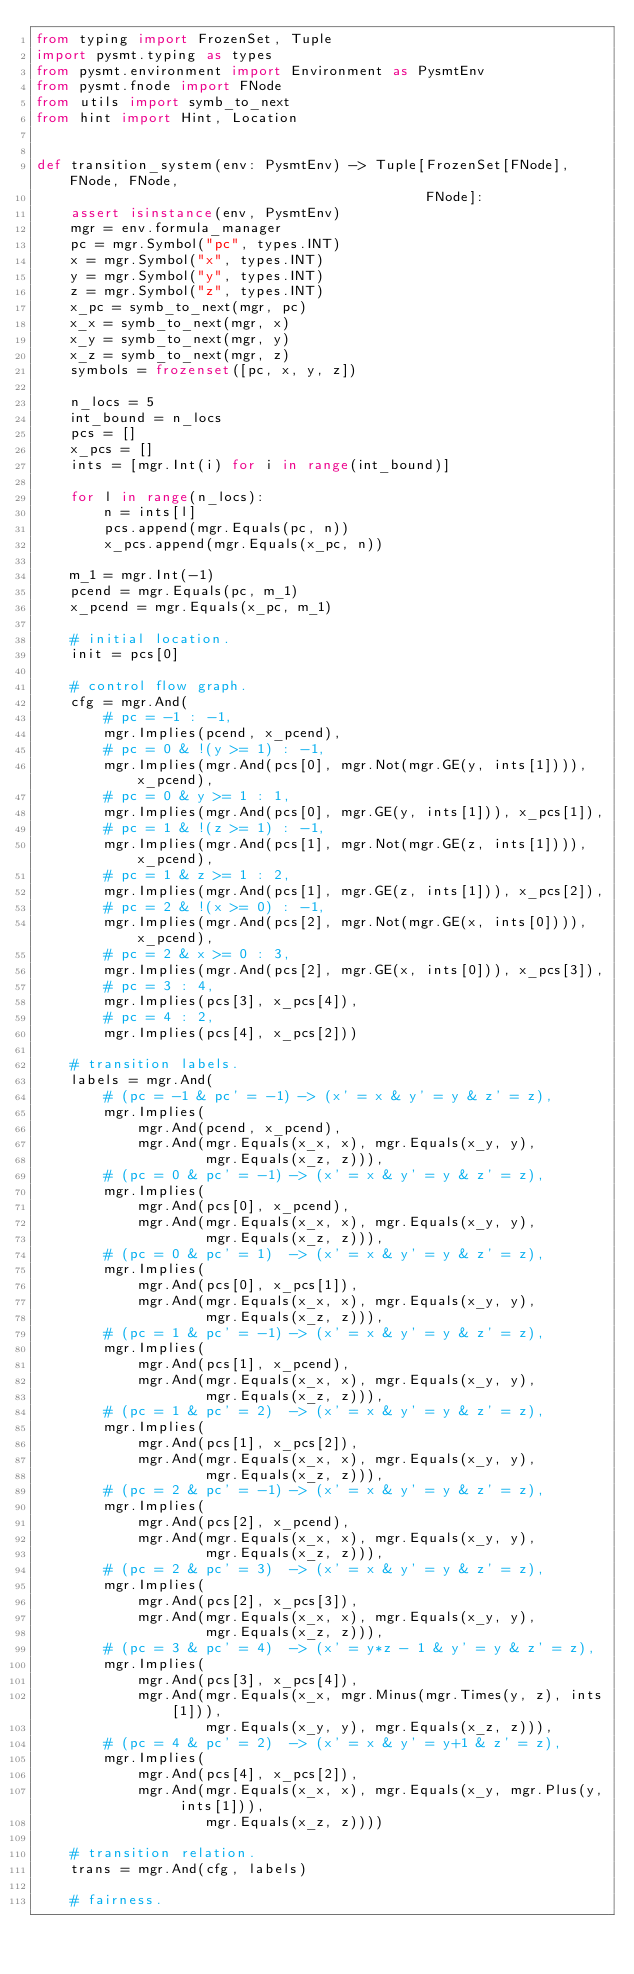Convert code to text. <code><loc_0><loc_0><loc_500><loc_500><_Python_>from typing import FrozenSet, Tuple
import pysmt.typing as types
from pysmt.environment import Environment as PysmtEnv
from pysmt.fnode import FNode
from utils import symb_to_next
from hint import Hint, Location


def transition_system(env: PysmtEnv) -> Tuple[FrozenSet[FNode], FNode, FNode,
                                              FNode]:
    assert isinstance(env, PysmtEnv)
    mgr = env.formula_manager
    pc = mgr.Symbol("pc", types.INT)
    x = mgr.Symbol("x", types.INT)
    y = mgr.Symbol("y", types.INT)
    z = mgr.Symbol("z", types.INT)
    x_pc = symb_to_next(mgr, pc)
    x_x = symb_to_next(mgr, x)
    x_y = symb_to_next(mgr, y)
    x_z = symb_to_next(mgr, z)
    symbols = frozenset([pc, x, y, z])

    n_locs = 5
    int_bound = n_locs
    pcs = []
    x_pcs = []
    ints = [mgr.Int(i) for i in range(int_bound)]

    for l in range(n_locs):
        n = ints[l]
        pcs.append(mgr.Equals(pc, n))
        x_pcs.append(mgr.Equals(x_pc, n))

    m_1 = mgr.Int(-1)
    pcend = mgr.Equals(pc, m_1)
    x_pcend = mgr.Equals(x_pc, m_1)

    # initial location.
    init = pcs[0]

    # control flow graph.
    cfg = mgr.And(
        # pc = -1 : -1,
        mgr.Implies(pcend, x_pcend),
        # pc = 0 & !(y >= 1) : -1,
        mgr.Implies(mgr.And(pcs[0], mgr.Not(mgr.GE(y, ints[1]))), x_pcend),
        # pc = 0 & y >= 1 : 1,
        mgr.Implies(mgr.And(pcs[0], mgr.GE(y, ints[1])), x_pcs[1]),
        # pc = 1 & !(z >= 1) : -1,
        mgr.Implies(mgr.And(pcs[1], mgr.Not(mgr.GE(z, ints[1]))), x_pcend),
        # pc = 1 & z >= 1 : 2,
        mgr.Implies(mgr.And(pcs[1], mgr.GE(z, ints[1])), x_pcs[2]),
        # pc = 2 & !(x >= 0) : -1,
        mgr.Implies(mgr.And(pcs[2], mgr.Not(mgr.GE(x, ints[0]))), x_pcend),
        # pc = 2 & x >= 0 : 3,
        mgr.Implies(mgr.And(pcs[2], mgr.GE(x, ints[0])), x_pcs[3]),
        # pc = 3 : 4,
        mgr.Implies(pcs[3], x_pcs[4]),
        # pc = 4 : 2,
        mgr.Implies(pcs[4], x_pcs[2]))

    # transition labels.
    labels = mgr.And(
        # (pc = -1 & pc' = -1) -> (x' = x & y' = y & z' = z),
        mgr.Implies(
            mgr.And(pcend, x_pcend),
            mgr.And(mgr.Equals(x_x, x), mgr.Equals(x_y, y),
                    mgr.Equals(x_z, z))),
        # (pc = 0 & pc' = -1) -> (x' = x & y' = y & z' = z),
        mgr.Implies(
            mgr.And(pcs[0], x_pcend),
            mgr.And(mgr.Equals(x_x, x), mgr.Equals(x_y, y),
                    mgr.Equals(x_z, z))),
        # (pc = 0 & pc' = 1)  -> (x' = x & y' = y & z' = z),
        mgr.Implies(
            mgr.And(pcs[0], x_pcs[1]),
            mgr.And(mgr.Equals(x_x, x), mgr.Equals(x_y, y),
                    mgr.Equals(x_z, z))),
        # (pc = 1 & pc' = -1) -> (x' = x & y' = y & z' = z),
        mgr.Implies(
            mgr.And(pcs[1], x_pcend),
            mgr.And(mgr.Equals(x_x, x), mgr.Equals(x_y, y),
                    mgr.Equals(x_z, z))),
        # (pc = 1 & pc' = 2)  -> (x' = x & y' = y & z' = z),
        mgr.Implies(
            mgr.And(pcs[1], x_pcs[2]),
            mgr.And(mgr.Equals(x_x, x), mgr.Equals(x_y, y),
                    mgr.Equals(x_z, z))),
        # (pc = 2 & pc' = -1) -> (x' = x & y' = y & z' = z),
        mgr.Implies(
            mgr.And(pcs[2], x_pcend),
            mgr.And(mgr.Equals(x_x, x), mgr.Equals(x_y, y),
                    mgr.Equals(x_z, z))),
        # (pc = 2 & pc' = 3)  -> (x' = x & y' = y & z' = z),
        mgr.Implies(
            mgr.And(pcs[2], x_pcs[3]),
            mgr.And(mgr.Equals(x_x, x), mgr.Equals(x_y, y),
                    mgr.Equals(x_z, z))),
        # (pc = 3 & pc' = 4)  -> (x' = y*z - 1 & y' = y & z' = z),
        mgr.Implies(
            mgr.And(pcs[3], x_pcs[4]),
            mgr.And(mgr.Equals(x_x, mgr.Minus(mgr.Times(y, z), ints[1])),
                    mgr.Equals(x_y, y), mgr.Equals(x_z, z))),
        # (pc = 4 & pc' = 2)  -> (x' = x & y' = y+1 & z' = z),
        mgr.Implies(
            mgr.And(pcs[4], x_pcs[2]),
            mgr.And(mgr.Equals(x_x, x), mgr.Equals(x_y, mgr.Plus(y, ints[1])),
                    mgr.Equals(x_z, z))))

    # transition relation.
    trans = mgr.And(cfg, labels)

    # fairness.</code> 